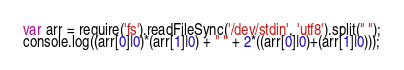Convert code to text. <code><loc_0><loc_0><loc_500><loc_500><_JavaScript_>var arr = require('fs').readFileSync('/dev/stdin', 'utf8').split(" ");
console.log((arr[0]|0)*(arr[1]|0) + " " + 2*((arr[0]|0)+(arr[1]|0)));</code> 